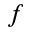<formula> <loc_0><loc_0><loc_500><loc_500>f</formula> 